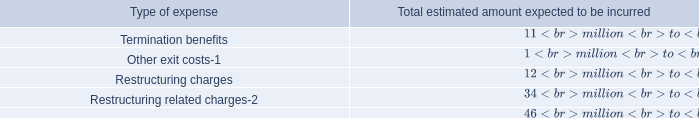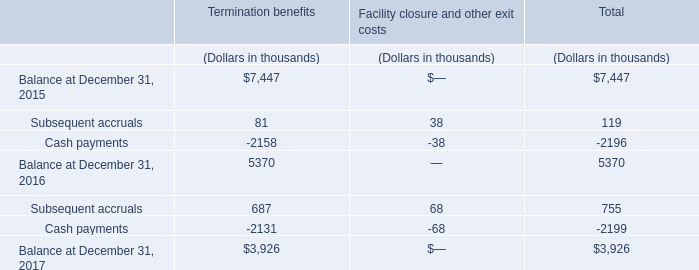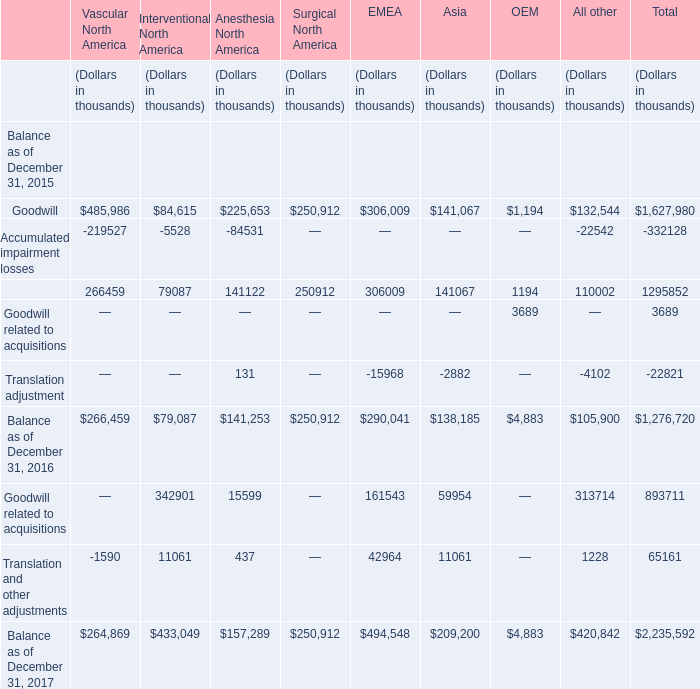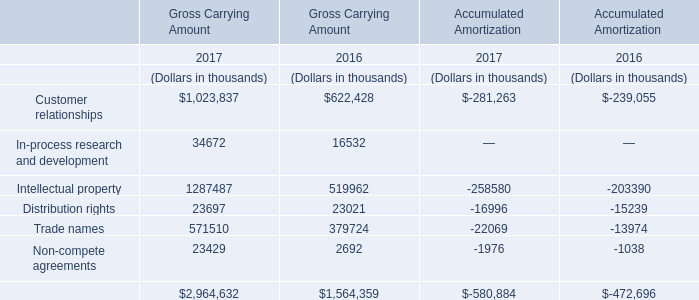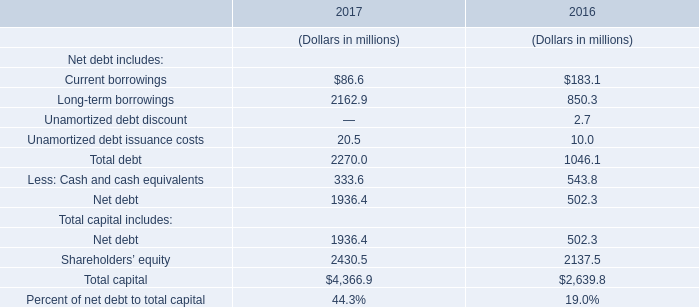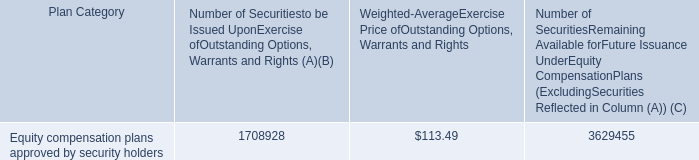In the year where the Gross Carrying Amount for Intellectual property is the highest, what's the Gross Carrying Amount for Distribution rights? (in thousand) 
Answer: 23697. 